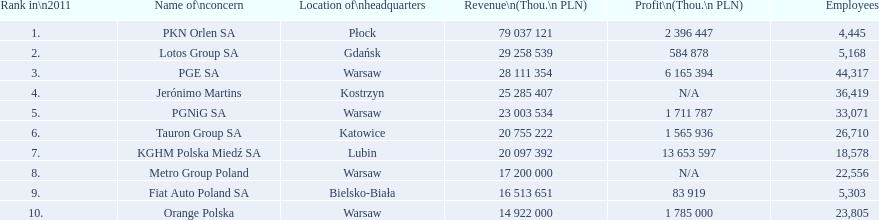What are the names of the major companies of poland? PKN Orlen SA, Lotos Group SA, PGE SA, Jerónimo Martins, PGNiG SA, Tauron Group SA, KGHM Polska Miedź SA, Metro Group Poland, Fiat Auto Poland SA, Orange Polska. What are the revenues of those companies in thou. pln? PKN Orlen SA, 79 037 121, Lotos Group SA, 29 258 539, PGE SA, 28 111 354, Jerónimo Martins, 25 285 407, PGNiG SA, 23 003 534, Tauron Group SA, 20 755 222, KGHM Polska Miedź SA, 20 097 392, Metro Group Poland, 17 200 000, Fiat Auto Poland SA, 16 513 651, Orange Polska, 14 922 000. Which of these revenues is greater than 75 000 000 thou. pln? 79 037 121. Which company has a revenue equal to 79 037 121 thou pln? PKN Orlen SA. 